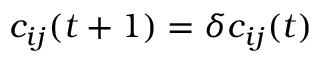<formula> <loc_0><loc_0><loc_500><loc_500>c _ { i j } ( t + 1 ) = \delta c _ { i j } ( t )</formula> 